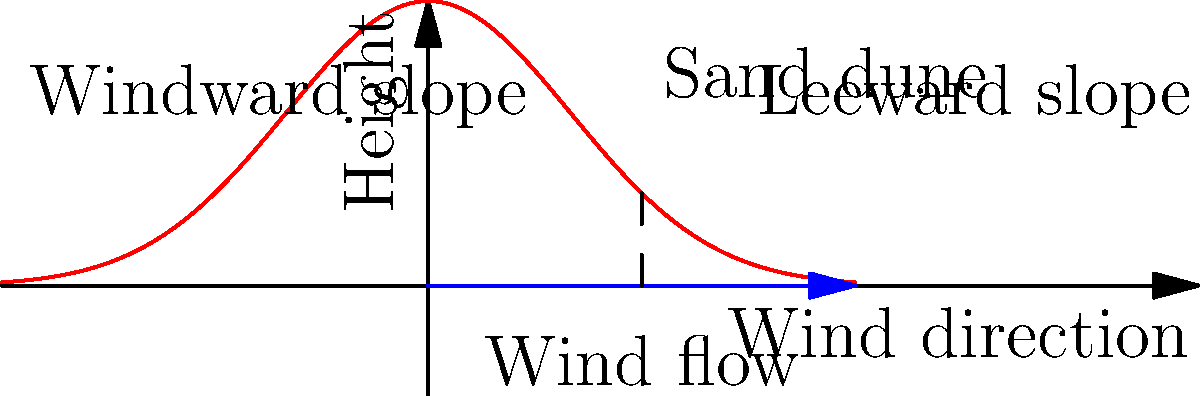In the formation of a sand dune, which slope typically has a gentler angle: the windward slope or the leeward slope? Explain why this occurs based on the wind's interaction with the sand particles. To understand the formation of sand dunes, we need to consider the interaction between wind and sand particles:

1. Wind direction: The wind blows from left to right in the diagram.

2. Windward slope:
   - This is the side of the dune facing the wind.
   - As wind hits this slope, it carries sand particles up the slope.
   - The wind speed increases as it moves up the slope due to compression of air.
   - This results in a gradual deposition of sand particles.

3. Leeward slope:
   - This is the side of the dune sheltered from the wind.
   - As wind passes over the crest of the dune, it expands and slows down.
   - This sudden decrease in wind speed causes rapid deposition of sand particles.

4. Slope angles:
   - The windward slope has a gentler angle because sand is continuously being carried up this side by the wind.
   - The leeward slope is steeper because sand particles fall quickly in this area due to the sudden drop in wind speed.

5. Angle of repose:
   - The leeward slope's angle is often close to the angle of repose for sand (about 30-34 degrees).
   - This is the steepest angle at which sand can rest without sliding down due to gravity.

6. Dynamic equilibrium:
   - Over time, the dune shape reaches a dynamic equilibrium where sand erosion and deposition balance each other.
   - This results in the characteristic asymmetric shape of sand dunes.
Answer: The windward slope has a gentler angle due to gradual sand deposition by wind. 